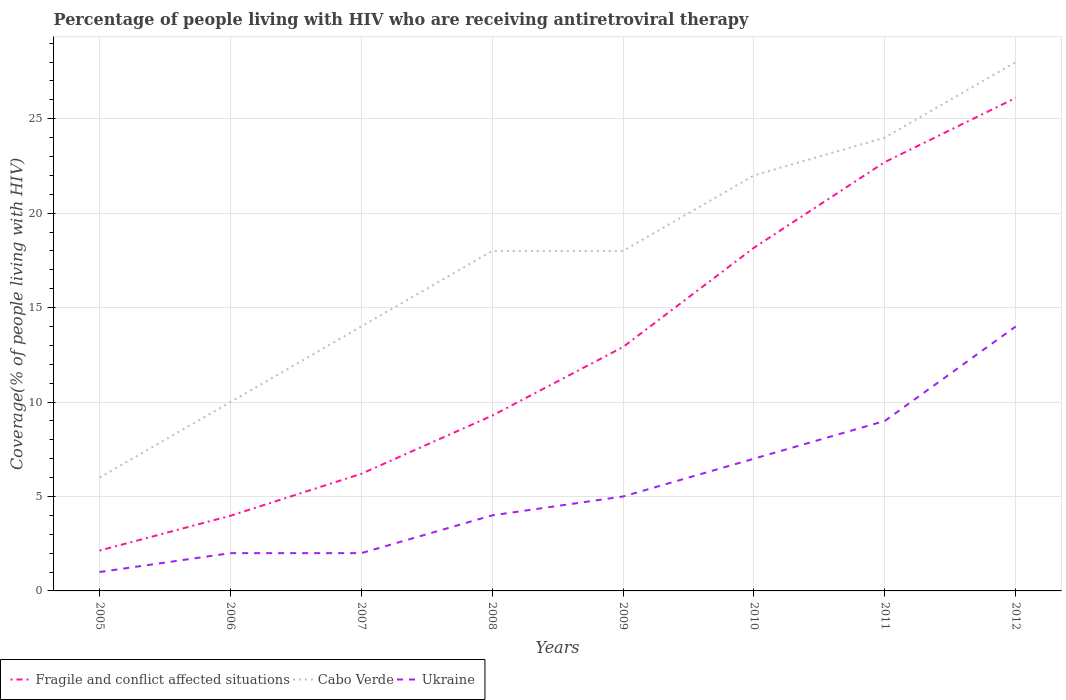How many different coloured lines are there?
Offer a terse response. 3. Across all years, what is the maximum percentage of the HIV infected people who are receiving antiretroviral therapy in Fragile and conflict affected situations?
Your response must be concise. 2.14. In which year was the percentage of the HIV infected people who are receiving antiretroviral therapy in Ukraine maximum?
Make the answer very short. 2005. What is the total percentage of the HIV infected people who are receiving antiretroviral therapy in Ukraine in the graph?
Your response must be concise. -6. What is the difference between the highest and the second highest percentage of the HIV infected people who are receiving antiretroviral therapy in Ukraine?
Your response must be concise. 13. How many lines are there?
Provide a short and direct response. 3. Does the graph contain any zero values?
Your response must be concise. No. Does the graph contain grids?
Offer a terse response. Yes. How many legend labels are there?
Offer a terse response. 3. What is the title of the graph?
Provide a succinct answer. Percentage of people living with HIV who are receiving antiretroviral therapy. Does "South Sudan" appear as one of the legend labels in the graph?
Give a very brief answer. No. What is the label or title of the Y-axis?
Your answer should be very brief. Coverage(% of people living with HIV). What is the Coverage(% of people living with HIV) in Fragile and conflict affected situations in 2005?
Make the answer very short. 2.14. What is the Coverage(% of people living with HIV) of Fragile and conflict affected situations in 2006?
Make the answer very short. 3.98. What is the Coverage(% of people living with HIV) of Cabo Verde in 2006?
Ensure brevity in your answer.  10. What is the Coverage(% of people living with HIV) in Fragile and conflict affected situations in 2007?
Ensure brevity in your answer.  6.2. What is the Coverage(% of people living with HIV) of Fragile and conflict affected situations in 2008?
Your answer should be very brief. 9.28. What is the Coverage(% of people living with HIV) in Cabo Verde in 2008?
Provide a succinct answer. 18. What is the Coverage(% of people living with HIV) of Ukraine in 2008?
Ensure brevity in your answer.  4. What is the Coverage(% of people living with HIV) of Fragile and conflict affected situations in 2009?
Give a very brief answer. 12.91. What is the Coverage(% of people living with HIV) of Cabo Verde in 2009?
Provide a short and direct response. 18. What is the Coverage(% of people living with HIV) of Ukraine in 2009?
Make the answer very short. 5. What is the Coverage(% of people living with HIV) of Fragile and conflict affected situations in 2010?
Make the answer very short. 18.17. What is the Coverage(% of people living with HIV) in Cabo Verde in 2010?
Ensure brevity in your answer.  22. What is the Coverage(% of people living with HIV) of Fragile and conflict affected situations in 2011?
Give a very brief answer. 22.7. What is the Coverage(% of people living with HIV) of Cabo Verde in 2011?
Your answer should be compact. 24. What is the Coverage(% of people living with HIV) of Fragile and conflict affected situations in 2012?
Ensure brevity in your answer.  26.1. What is the Coverage(% of people living with HIV) in Cabo Verde in 2012?
Provide a short and direct response. 28. Across all years, what is the maximum Coverage(% of people living with HIV) in Fragile and conflict affected situations?
Ensure brevity in your answer.  26.1. Across all years, what is the maximum Coverage(% of people living with HIV) in Ukraine?
Keep it short and to the point. 14. Across all years, what is the minimum Coverage(% of people living with HIV) of Fragile and conflict affected situations?
Provide a short and direct response. 2.14. Across all years, what is the minimum Coverage(% of people living with HIV) in Cabo Verde?
Provide a succinct answer. 6. What is the total Coverage(% of people living with HIV) in Fragile and conflict affected situations in the graph?
Offer a terse response. 101.49. What is the total Coverage(% of people living with HIV) in Cabo Verde in the graph?
Provide a short and direct response. 140. What is the difference between the Coverage(% of people living with HIV) in Fragile and conflict affected situations in 2005 and that in 2006?
Ensure brevity in your answer.  -1.84. What is the difference between the Coverage(% of people living with HIV) of Cabo Verde in 2005 and that in 2006?
Keep it short and to the point. -4. What is the difference between the Coverage(% of people living with HIV) in Ukraine in 2005 and that in 2006?
Provide a succinct answer. -1. What is the difference between the Coverage(% of people living with HIV) in Fragile and conflict affected situations in 2005 and that in 2007?
Offer a very short reply. -4.06. What is the difference between the Coverage(% of people living with HIV) of Ukraine in 2005 and that in 2007?
Provide a short and direct response. -1. What is the difference between the Coverage(% of people living with HIV) in Fragile and conflict affected situations in 2005 and that in 2008?
Your answer should be compact. -7.14. What is the difference between the Coverage(% of people living with HIV) of Cabo Verde in 2005 and that in 2008?
Ensure brevity in your answer.  -12. What is the difference between the Coverage(% of people living with HIV) in Fragile and conflict affected situations in 2005 and that in 2009?
Your response must be concise. -10.78. What is the difference between the Coverage(% of people living with HIV) in Cabo Verde in 2005 and that in 2009?
Give a very brief answer. -12. What is the difference between the Coverage(% of people living with HIV) in Fragile and conflict affected situations in 2005 and that in 2010?
Give a very brief answer. -16.03. What is the difference between the Coverage(% of people living with HIV) in Cabo Verde in 2005 and that in 2010?
Your answer should be very brief. -16. What is the difference between the Coverage(% of people living with HIV) of Ukraine in 2005 and that in 2010?
Offer a terse response. -6. What is the difference between the Coverage(% of people living with HIV) in Fragile and conflict affected situations in 2005 and that in 2011?
Provide a short and direct response. -20.57. What is the difference between the Coverage(% of people living with HIV) of Cabo Verde in 2005 and that in 2011?
Your response must be concise. -18. What is the difference between the Coverage(% of people living with HIV) of Ukraine in 2005 and that in 2011?
Keep it short and to the point. -8. What is the difference between the Coverage(% of people living with HIV) of Fragile and conflict affected situations in 2005 and that in 2012?
Offer a very short reply. -23.97. What is the difference between the Coverage(% of people living with HIV) in Fragile and conflict affected situations in 2006 and that in 2007?
Your answer should be compact. -2.22. What is the difference between the Coverage(% of people living with HIV) of Cabo Verde in 2006 and that in 2007?
Give a very brief answer. -4. What is the difference between the Coverage(% of people living with HIV) of Fragile and conflict affected situations in 2006 and that in 2008?
Offer a terse response. -5.3. What is the difference between the Coverage(% of people living with HIV) of Fragile and conflict affected situations in 2006 and that in 2009?
Provide a short and direct response. -8.94. What is the difference between the Coverage(% of people living with HIV) of Cabo Verde in 2006 and that in 2009?
Provide a succinct answer. -8. What is the difference between the Coverage(% of people living with HIV) of Ukraine in 2006 and that in 2009?
Your answer should be very brief. -3. What is the difference between the Coverage(% of people living with HIV) in Fragile and conflict affected situations in 2006 and that in 2010?
Keep it short and to the point. -14.19. What is the difference between the Coverage(% of people living with HIV) of Cabo Verde in 2006 and that in 2010?
Your answer should be compact. -12. What is the difference between the Coverage(% of people living with HIV) of Fragile and conflict affected situations in 2006 and that in 2011?
Provide a succinct answer. -18.73. What is the difference between the Coverage(% of people living with HIV) of Ukraine in 2006 and that in 2011?
Your response must be concise. -7. What is the difference between the Coverage(% of people living with HIV) of Fragile and conflict affected situations in 2006 and that in 2012?
Make the answer very short. -22.12. What is the difference between the Coverage(% of people living with HIV) in Ukraine in 2006 and that in 2012?
Provide a succinct answer. -12. What is the difference between the Coverage(% of people living with HIV) of Fragile and conflict affected situations in 2007 and that in 2008?
Make the answer very short. -3.08. What is the difference between the Coverage(% of people living with HIV) in Cabo Verde in 2007 and that in 2008?
Keep it short and to the point. -4. What is the difference between the Coverage(% of people living with HIV) in Ukraine in 2007 and that in 2008?
Offer a very short reply. -2. What is the difference between the Coverage(% of people living with HIV) in Fragile and conflict affected situations in 2007 and that in 2009?
Your answer should be very brief. -6.71. What is the difference between the Coverage(% of people living with HIV) in Ukraine in 2007 and that in 2009?
Your answer should be compact. -3. What is the difference between the Coverage(% of people living with HIV) of Fragile and conflict affected situations in 2007 and that in 2010?
Your answer should be compact. -11.97. What is the difference between the Coverage(% of people living with HIV) of Ukraine in 2007 and that in 2010?
Ensure brevity in your answer.  -5. What is the difference between the Coverage(% of people living with HIV) of Fragile and conflict affected situations in 2007 and that in 2011?
Your response must be concise. -16.5. What is the difference between the Coverage(% of people living with HIV) of Cabo Verde in 2007 and that in 2011?
Your answer should be very brief. -10. What is the difference between the Coverage(% of people living with HIV) of Fragile and conflict affected situations in 2007 and that in 2012?
Ensure brevity in your answer.  -19.9. What is the difference between the Coverage(% of people living with HIV) of Ukraine in 2007 and that in 2012?
Your answer should be compact. -12. What is the difference between the Coverage(% of people living with HIV) in Fragile and conflict affected situations in 2008 and that in 2009?
Offer a terse response. -3.63. What is the difference between the Coverage(% of people living with HIV) in Ukraine in 2008 and that in 2009?
Provide a short and direct response. -1. What is the difference between the Coverage(% of people living with HIV) in Fragile and conflict affected situations in 2008 and that in 2010?
Offer a very short reply. -8.89. What is the difference between the Coverage(% of people living with HIV) of Cabo Verde in 2008 and that in 2010?
Give a very brief answer. -4. What is the difference between the Coverage(% of people living with HIV) of Ukraine in 2008 and that in 2010?
Offer a very short reply. -3. What is the difference between the Coverage(% of people living with HIV) of Fragile and conflict affected situations in 2008 and that in 2011?
Give a very brief answer. -13.42. What is the difference between the Coverage(% of people living with HIV) of Cabo Verde in 2008 and that in 2011?
Your answer should be very brief. -6. What is the difference between the Coverage(% of people living with HIV) in Fragile and conflict affected situations in 2008 and that in 2012?
Make the answer very short. -16.82. What is the difference between the Coverage(% of people living with HIV) in Ukraine in 2008 and that in 2012?
Give a very brief answer. -10. What is the difference between the Coverage(% of people living with HIV) of Fragile and conflict affected situations in 2009 and that in 2010?
Make the answer very short. -5.25. What is the difference between the Coverage(% of people living with HIV) of Cabo Verde in 2009 and that in 2010?
Offer a very short reply. -4. What is the difference between the Coverage(% of people living with HIV) in Ukraine in 2009 and that in 2010?
Keep it short and to the point. -2. What is the difference between the Coverage(% of people living with HIV) of Fragile and conflict affected situations in 2009 and that in 2011?
Your answer should be compact. -9.79. What is the difference between the Coverage(% of people living with HIV) in Fragile and conflict affected situations in 2009 and that in 2012?
Offer a terse response. -13.19. What is the difference between the Coverage(% of people living with HIV) in Cabo Verde in 2009 and that in 2012?
Provide a succinct answer. -10. What is the difference between the Coverage(% of people living with HIV) in Fragile and conflict affected situations in 2010 and that in 2011?
Make the answer very short. -4.54. What is the difference between the Coverage(% of people living with HIV) of Fragile and conflict affected situations in 2010 and that in 2012?
Provide a succinct answer. -7.93. What is the difference between the Coverage(% of people living with HIV) in Cabo Verde in 2010 and that in 2012?
Your answer should be very brief. -6. What is the difference between the Coverage(% of people living with HIV) of Ukraine in 2010 and that in 2012?
Your response must be concise. -7. What is the difference between the Coverage(% of people living with HIV) in Fragile and conflict affected situations in 2011 and that in 2012?
Give a very brief answer. -3.4. What is the difference between the Coverage(% of people living with HIV) in Fragile and conflict affected situations in 2005 and the Coverage(% of people living with HIV) in Cabo Verde in 2006?
Your response must be concise. -7.86. What is the difference between the Coverage(% of people living with HIV) of Fragile and conflict affected situations in 2005 and the Coverage(% of people living with HIV) of Ukraine in 2006?
Ensure brevity in your answer.  0.14. What is the difference between the Coverage(% of people living with HIV) in Cabo Verde in 2005 and the Coverage(% of people living with HIV) in Ukraine in 2006?
Your response must be concise. 4. What is the difference between the Coverage(% of people living with HIV) in Fragile and conflict affected situations in 2005 and the Coverage(% of people living with HIV) in Cabo Verde in 2007?
Provide a short and direct response. -11.86. What is the difference between the Coverage(% of people living with HIV) of Fragile and conflict affected situations in 2005 and the Coverage(% of people living with HIV) of Ukraine in 2007?
Offer a very short reply. 0.14. What is the difference between the Coverage(% of people living with HIV) of Fragile and conflict affected situations in 2005 and the Coverage(% of people living with HIV) of Cabo Verde in 2008?
Ensure brevity in your answer.  -15.86. What is the difference between the Coverage(% of people living with HIV) of Fragile and conflict affected situations in 2005 and the Coverage(% of people living with HIV) of Ukraine in 2008?
Ensure brevity in your answer.  -1.86. What is the difference between the Coverage(% of people living with HIV) in Fragile and conflict affected situations in 2005 and the Coverage(% of people living with HIV) in Cabo Verde in 2009?
Make the answer very short. -15.86. What is the difference between the Coverage(% of people living with HIV) in Fragile and conflict affected situations in 2005 and the Coverage(% of people living with HIV) in Ukraine in 2009?
Provide a succinct answer. -2.86. What is the difference between the Coverage(% of people living with HIV) in Fragile and conflict affected situations in 2005 and the Coverage(% of people living with HIV) in Cabo Verde in 2010?
Ensure brevity in your answer.  -19.86. What is the difference between the Coverage(% of people living with HIV) in Fragile and conflict affected situations in 2005 and the Coverage(% of people living with HIV) in Ukraine in 2010?
Your answer should be very brief. -4.86. What is the difference between the Coverage(% of people living with HIV) of Cabo Verde in 2005 and the Coverage(% of people living with HIV) of Ukraine in 2010?
Make the answer very short. -1. What is the difference between the Coverage(% of people living with HIV) of Fragile and conflict affected situations in 2005 and the Coverage(% of people living with HIV) of Cabo Verde in 2011?
Provide a succinct answer. -21.86. What is the difference between the Coverage(% of people living with HIV) in Fragile and conflict affected situations in 2005 and the Coverage(% of people living with HIV) in Ukraine in 2011?
Provide a short and direct response. -6.86. What is the difference between the Coverage(% of people living with HIV) of Fragile and conflict affected situations in 2005 and the Coverage(% of people living with HIV) of Cabo Verde in 2012?
Ensure brevity in your answer.  -25.86. What is the difference between the Coverage(% of people living with HIV) in Fragile and conflict affected situations in 2005 and the Coverage(% of people living with HIV) in Ukraine in 2012?
Make the answer very short. -11.86. What is the difference between the Coverage(% of people living with HIV) of Fragile and conflict affected situations in 2006 and the Coverage(% of people living with HIV) of Cabo Verde in 2007?
Provide a short and direct response. -10.02. What is the difference between the Coverage(% of people living with HIV) of Fragile and conflict affected situations in 2006 and the Coverage(% of people living with HIV) of Ukraine in 2007?
Offer a very short reply. 1.98. What is the difference between the Coverage(% of people living with HIV) in Cabo Verde in 2006 and the Coverage(% of people living with HIV) in Ukraine in 2007?
Ensure brevity in your answer.  8. What is the difference between the Coverage(% of people living with HIV) of Fragile and conflict affected situations in 2006 and the Coverage(% of people living with HIV) of Cabo Verde in 2008?
Make the answer very short. -14.02. What is the difference between the Coverage(% of people living with HIV) of Fragile and conflict affected situations in 2006 and the Coverage(% of people living with HIV) of Ukraine in 2008?
Make the answer very short. -0.02. What is the difference between the Coverage(% of people living with HIV) in Cabo Verde in 2006 and the Coverage(% of people living with HIV) in Ukraine in 2008?
Make the answer very short. 6. What is the difference between the Coverage(% of people living with HIV) in Fragile and conflict affected situations in 2006 and the Coverage(% of people living with HIV) in Cabo Verde in 2009?
Offer a very short reply. -14.02. What is the difference between the Coverage(% of people living with HIV) in Fragile and conflict affected situations in 2006 and the Coverage(% of people living with HIV) in Ukraine in 2009?
Ensure brevity in your answer.  -1.02. What is the difference between the Coverage(% of people living with HIV) in Cabo Verde in 2006 and the Coverage(% of people living with HIV) in Ukraine in 2009?
Give a very brief answer. 5. What is the difference between the Coverage(% of people living with HIV) of Fragile and conflict affected situations in 2006 and the Coverage(% of people living with HIV) of Cabo Verde in 2010?
Keep it short and to the point. -18.02. What is the difference between the Coverage(% of people living with HIV) in Fragile and conflict affected situations in 2006 and the Coverage(% of people living with HIV) in Ukraine in 2010?
Keep it short and to the point. -3.02. What is the difference between the Coverage(% of people living with HIV) of Fragile and conflict affected situations in 2006 and the Coverage(% of people living with HIV) of Cabo Verde in 2011?
Provide a succinct answer. -20.02. What is the difference between the Coverage(% of people living with HIV) of Fragile and conflict affected situations in 2006 and the Coverage(% of people living with HIV) of Ukraine in 2011?
Ensure brevity in your answer.  -5.02. What is the difference between the Coverage(% of people living with HIV) of Cabo Verde in 2006 and the Coverage(% of people living with HIV) of Ukraine in 2011?
Offer a very short reply. 1. What is the difference between the Coverage(% of people living with HIV) in Fragile and conflict affected situations in 2006 and the Coverage(% of people living with HIV) in Cabo Verde in 2012?
Ensure brevity in your answer.  -24.02. What is the difference between the Coverage(% of people living with HIV) in Fragile and conflict affected situations in 2006 and the Coverage(% of people living with HIV) in Ukraine in 2012?
Your answer should be compact. -10.02. What is the difference between the Coverage(% of people living with HIV) in Fragile and conflict affected situations in 2007 and the Coverage(% of people living with HIV) in Cabo Verde in 2008?
Keep it short and to the point. -11.8. What is the difference between the Coverage(% of people living with HIV) of Fragile and conflict affected situations in 2007 and the Coverage(% of people living with HIV) of Ukraine in 2008?
Your response must be concise. 2.2. What is the difference between the Coverage(% of people living with HIV) in Cabo Verde in 2007 and the Coverage(% of people living with HIV) in Ukraine in 2008?
Make the answer very short. 10. What is the difference between the Coverage(% of people living with HIV) in Fragile and conflict affected situations in 2007 and the Coverage(% of people living with HIV) in Cabo Verde in 2009?
Make the answer very short. -11.8. What is the difference between the Coverage(% of people living with HIV) of Fragile and conflict affected situations in 2007 and the Coverage(% of people living with HIV) of Ukraine in 2009?
Your answer should be compact. 1.2. What is the difference between the Coverage(% of people living with HIV) in Fragile and conflict affected situations in 2007 and the Coverage(% of people living with HIV) in Cabo Verde in 2010?
Keep it short and to the point. -15.8. What is the difference between the Coverage(% of people living with HIV) in Fragile and conflict affected situations in 2007 and the Coverage(% of people living with HIV) in Ukraine in 2010?
Your response must be concise. -0.8. What is the difference between the Coverage(% of people living with HIV) of Fragile and conflict affected situations in 2007 and the Coverage(% of people living with HIV) of Cabo Verde in 2011?
Your answer should be very brief. -17.8. What is the difference between the Coverage(% of people living with HIV) of Fragile and conflict affected situations in 2007 and the Coverage(% of people living with HIV) of Ukraine in 2011?
Offer a very short reply. -2.8. What is the difference between the Coverage(% of people living with HIV) in Fragile and conflict affected situations in 2007 and the Coverage(% of people living with HIV) in Cabo Verde in 2012?
Your answer should be very brief. -21.8. What is the difference between the Coverage(% of people living with HIV) of Fragile and conflict affected situations in 2007 and the Coverage(% of people living with HIV) of Ukraine in 2012?
Provide a short and direct response. -7.8. What is the difference between the Coverage(% of people living with HIV) of Fragile and conflict affected situations in 2008 and the Coverage(% of people living with HIV) of Cabo Verde in 2009?
Ensure brevity in your answer.  -8.72. What is the difference between the Coverage(% of people living with HIV) of Fragile and conflict affected situations in 2008 and the Coverage(% of people living with HIV) of Ukraine in 2009?
Provide a short and direct response. 4.28. What is the difference between the Coverage(% of people living with HIV) of Cabo Verde in 2008 and the Coverage(% of people living with HIV) of Ukraine in 2009?
Provide a succinct answer. 13. What is the difference between the Coverage(% of people living with HIV) of Fragile and conflict affected situations in 2008 and the Coverage(% of people living with HIV) of Cabo Verde in 2010?
Provide a short and direct response. -12.72. What is the difference between the Coverage(% of people living with HIV) of Fragile and conflict affected situations in 2008 and the Coverage(% of people living with HIV) of Ukraine in 2010?
Your response must be concise. 2.28. What is the difference between the Coverage(% of people living with HIV) in Fragile and conflict affected situations in 2008 and the Coverage(% of people living with HIV) in Cabo Verde in 2011?
Offer a very short reply. -14.72. What is the difference between the Coverage(% of people living with HIV) of Fragile and conflict affected situations in 2008 and the Coverage(% of people living with HIV) of Ukraine in 2011?
Keep it short and to the point. 0.28. What is the difference between the Coverage(% of people living with HIV) of Fragile and conflict affected situations in 2008 and the Coverage(% of people living with HIV) of Cabo Verde in 2012?
Give a very brief answer. -18.72. What is the difference between the Coverage(% of people living with HIV) of Fragile and conflict affected situations in 2008 and the Coverage(% of people living with HIV) of Ukraine in 2012?
Offer a very short reply. -4.72. What is the difference between the Coverage(% of people living with HIV) of Fragile and conflict affected situations in 2009 and the Coverage(% of people living with HIV) of Cabo Verde in 2010?
Make the answer very short. -9.09. What is the difference between the Coverage(% of people living with HIV) in Fragile and conflict affected situations in 2009 and the Coverage(% of people living with HIV) in Ukraine in 2010?
Provide a short and direct response. 5.91. What is the difference between the Coverage(% of people living with HIV) of Cabo Verde in 2009 and the Coverage(% of people living with HIV) of Ukraine in 2010?
Offer a very short reply. 11. What is the difference between the Coverage(% of people living with HIV) in Fragile and conflict affected situations in 2009 and the Coverage(% of people living with HIV) in Cabo Verde in 2011?
Give a very brief answer. -11.09. What is the difference between the Coverage(% of people living with HIV) in Fragile and conflict affected situations in 2009 and the Coverage(% of people living with HIV) in Ukraine in 2011?
Offer a terse response. 3.91. What is the difference between the Coverage(% of people living with HIV) in Fragile and conflict affected situations in 2009 and the Coverage(% of people living with HIV) in Cabo Verde in 2012?
Offer a very short reply. -15.09. What is the difference between the Coverage(% of people living with HIV) of Fragile and conflict affected situations in 2009 and the Coverage(% of people living with HIV) of Ukraine in 2012?
Give a very brief answer. -1.09. What is the difference between the Coverage(% of people living with HIV) of Cabo Verde in 2009 and the Coverage(% of people living with HIV) of Ukraine in 2012?
Provide a short and direct response. 4. What is the difference between the Coverage(% of people living with HIV) of Fragile and conflict affected situations in 2010 and the Coverage(% of people living with HIV) of Cabo Verde in 2011?
Your answer should be very brief. -5.83. What is the difference between the Coverage(% of people living with HIV) of Fragile and conflict affected situations in 2010 and the Coverage(% of people living with HIV) of Ukraine in 2011?
Offer a terse response. 9.17. What is the difference between the Coverage(% of people living with HIV) of Cabo Verde in 2010 and the Coverage(% of people living with HIV) of Ukraine in 2011?
Your response must be concise. 13. What is the difference between the Coverage(% of people living with HIV) of Fragile and conflict affected situations in 2010 and the Coverage(% of people living with HIV) of Cabo Verde in 2012?
Offer a very short reply. -9.83. What is the difference between the Coverage(% of people living with HIV) in Fragile and conflict affected situations in 2010 and the Coverage(% of people living with HIV) in Ukraine in 2012?
Your response must be concise. 4.17. What is the difference between the Coverage(% of people living with HIV) of Cabo Verde in 2010 and the Coverage(% of people living with HIV) of Ukraine in 2012?
Keep it short and to the point. 8. What is the difference between the Coverage(% of people living with HIV) of Fragile and conflict affected situations in 2011 and the Coverage(% of people living with HIV) of Cabo Verde in 2012?
Provide a succinct answer. -5.3. What is the difference between the Coverage(% of people living with HIV) of Fragile and conflict affected situations in 2011 and the Coverage(% of people living with HIV) of Ukraine in 2012?
Provide a succinct answer. 8.7. What is the average Coverage(% of people living with HIV) in Fragile and conflict affected situations per year?
Offer a very short reply. 12.69. What is the average Coverage(% of people living with HIV) of Cabo Verde per year?
Offer a very short reply. 17.5. What is the average Coverage(% of people living with HIV) of Ukraine per year?
Offer a very short reply. 5.5. In the year 2005, what is the difference between the Coverage(% of people living with HIV) of Fragile and conflict affected situations and Coverage(% of people living with HIV) of Cabo Verde?
Provide a short and direct response. -3.86. In the year 2005, what is the difference between the Coverage(% of people living with HIV) of Fragile and conflict affected situations and Coverage(% of people living with HIV) of Ukraine?
Provide a short and direct response. 1.14. In the year 2005, what is the difference between the Coverage(% of people living with HIV) of Cabo Verde and Coverage(% of people living with HIV) of Ukraine?
Provide a short and direct response. 5. In the year 2006, what is the difference between the Coverage(% of people living with HIV) in Fragile and conflict affected situations and Coverage(% of people living with HIV) in Cabo Verde?
Provide a short and direct response. -6.02. In the year 2006, what is the difference between the Coverage(% of people living with HIV) in Fragile and conflict affected situations and Coverage(% of people living with HIV) in Ukraine?
Ensure brevity in your answer.  1.98. In the year 2006, what is the difference between the Coverage(% of people living with HIV) of Cabo Verde and Coverage(% of people living with HIV) of Ukraine?
Ensure brevity in your answer.  8. In the year 2007, what is the difference between the Coverage(% of people living with HIV) in Fragile and conflict affected situations and Coverage(% of people living with HIV) in Cabo Verde?
Your response must be concise. -7.8. In the year 2007, what is the difference between the Coverage(% of people living with HIV) in Fragile and conflict affected situations and Coverage(% of people living with HIV) in Ukraine?
Offer a terse response. 4.2. In the year 2008, what is the difference between the Coverage(% of people living with HIV) of Fragile and conflict affected situations and Coverage(% of people living with HIV) of Cabo Verde?
Ensure brevity in your answer.  -8.72. In the year 2008, what is the difference between the Coverage(% of people living with HIV) in Fragile and conflict affected situations and Coverage(% of people living with HIV) in Ukraine?
Ensure brevity in your answer.  5.28. In the year 2008, what is the difference between the Coverage(% of people living with HIV) of Cabo Verde and Coverage(% of people living with HIV) of Ukraine?
Your answer should be compact. 14. In the year 2009, what is the difference between the Coverage(% of people living with HIV) in Fragile and conflict affected situations and Coverage(% of people living with HIV) in Cabo Verde?
Your answer should be very brief. -5.09. In the year 2009, what is the difference between the Coverage(% of people living with HIV) in Fragile and conflict affected situations and Coverage(% of people living with HIV) in Ukraine?
Make the answer very short. 7.91. In the year 2009, what is the difference between the Coverage(% of people living with HIV) of Cabo Verde and Coverage(% of people living with HIV) of Ukraine?
Ensure brevity in your answer.  13. In the year 2010, what is the difference between the Coverage(% of people living with HIV) in Fragile and conflict affected situations and Coverage(% of people living with HIV) in Cabo Verde?
Offer a very short reply. -3.83. In the year 2010, what is the difference between the Coverage(% of people living with HIV) of Fragile and conflict affected situations and Coverage(% of people living with HIV) of Ukraine?
Offer a terse response. 11.17. In the year 2011, what is the difference between the Coverage(% of people living with HIV) of Fragile and conflict affected situations and Coverage(% of people living with HIV) of Cabo Verde?
Offer a terse response. -1.3. In the year 2011, what is the difference between the Coverage(% of people living with HIV) in Fragile and conflict affected situations and Coverage(% of people living with HIV) in Ukraine?
Your answer should be very brief. 13.7. In the year 2012, what is the difference between the Coverage(% of people living with HIV) in Fragile and conflict affected situations and Coverage(% of people living with HIV) in Cabo Verde?
Offer a very short reply. -1.9. In the year 2012, what is the difference between the Coverage(% of people living with HIV) in Fragile and conflict affected situations and Coverage(% of people living with HIV) in Ukraine?
Provide a short and direct response. 12.1. What is the ratio of the Coverage(% of people living with HIV) in Fragile and conflict affected situations in 2005 to that in 2006?
Your answer should be compact. 0.54. What is the ratio of the Coverage(% of people living with HIV) of Cabo Verde in 2005 to that in 2006?
Your response must be concise. 0.6. What is the ratio of the Coverage(% of people living with HIV) in Fragile and conflict affected situations in 2005 to that in 2007?
Your answer should be very brief. 0.34. What is the ratio of the Coverage(% of people living with HIV) in Cabo Verde in 2005 to that in 2007?
Make the answer very short. 0.43. What is the ratio of the Coverage(% of people living with HIV) of Ukraine in 2005 to that in 2007?
Offer a very short reply. 0.5. What is the ratio of the Coverage(% of people living with HIV) in Fragile and conflict affected situations in 2005 to that in 2008?
Offer a terse response. 0.23. What is the ratio of the Coverage(% of people living with HIV) of Fragile and conflict affected situations in 2005 to that in 2009?
Provide a short and direct response. 0.17. What is the ratio of the Coverage(% of people living with HIV) of Cabo Verde in 2005 to that in 2009?
Make the answer very short. 0.33. What is the ratio of the Coverage(% of people living with HIV) in Fragile and conflict affected situations in 2005 to that in 2010?
Keep it short and to the point. 0.12. What is the ratio of the Coverage(% of people living with HIV) in Cabo Verde in 2005 to that in 2010?
Ensure brevity in your answer.  0.27. What is the ratio of the Coverage(% of people living with HIV) of Ukraine in 2005 to that in 2010?
Make the answer very short. 0.14. What is the ratio of the Coverage(% of people living with HIV) in Fragile and conflict affected situations in 2005 to that in 2011?
Your answer should be very brief. 0.09. What is the ratio of the Coverage(% of people living with HIV) in Ukraine in 2005 to that in 2011?
Keep it short and to the point. 0.11. What is the ratio of the Coverage(% of people living with HIV) of Fragile and conflict affected situations in 2005 to that in 2012?
Give a very brief answer. 0.08. What is the ratio of the Coverage(% of people living with HIV) of Cabo Verde in 2005 to that in 2012?
Give a very brief answer. 0.21. What is the ratio of the Coverage(% of people living with HIV) of Ukraine in 2005 to that in 2012?
Offer a very short reply. 0.07. What is the ratio of the Coverage(% of people living with HIV) in Fragile and conflict affected situations in 2006 to that in 2007?
Give a very brief answer. 0.64. What is the ratio of the Coverage(% of people living with HIV) in Fragile and conflict affected situations in 2006 to that in 2008?
Make the answer very short. 0.43. What is the ratio of the Coverage(% of people living with HIV) of Cabo Verde in 2006 to that in 2008?
Your answer should be compact. 0.56. What is the ratio of the Coverage(% of people living with HIV) of Fragile and conflict affected situations in 2006 to that in 2009?
Offer a terse response. 0.31. What is the ratio of the Coverage(% of people living with HIV) in Cabo Verde in 2006 to that in 2009?
Make the answer very short. 0.56. What is the ratio of the Coverage(% of people living with HIV) of Ukraine in 2006 to that in 2009?
Your response must be concise. 0.4. What is the ratio of the Coverage(% of people living with HIV) of Fragile and conflict affected situations in 2006 to that in 2010?
Offer a very short reply. 0.22. What is the ratio of the Coverage(% of people living with HIV) of Cabo Verde in 2006 to that in 2010?
Offer a terse response. 0.45. What is the ratio of the Coverage(% of people living with HIV) of Ukraine in 2006 to that in 2010?
Make the answer very short. 0.29. What is the ratio of the Coverage(% of people living with HIV) of Fragile and conflict affected situations in 2006 to that in 2011?
Ensure brevity in your answer.  0.18. What is the ratio of the Coverage(% of people living with HIV) in Cabo Verde in 2006 to that in 2011?
Keep it short and to the point. 0.42. What is the ratio of the Coverage(% of people living with HIV) in Ukraine in 2006 to that in 2011?
Offer a very short reply. 0.22. What is the ratio of the Coverage(% of people living with HIV) in Fragile and conflict affected situations in 2006 to that in 2012?
Offer a very short reply. 0.15. What is the ratio of the Coverage(% of people living with HIV) of Cabo Verde in 2006 to that in 2012?
Your response must be concise. 0.36. What is the ratio of the Coverage(% of people living with HIV) of Ukraine in 2006 to that in 2012?
Give a very brief answer. 0.14. What is the ratio of the Coverage(% of people living with HIV) of Fragile and conflict affected situations in 2007 to that in 2008?
Keep it short and to the point. 0.67. What is the ratio of the Coverage(% of people living with HIV) of Ukraine in 2007 to that in 2008?
Offer a terse response. 0.5. What is the ratio of the Coverage(% of people living with HIV) of Fragile and conflict affected situations in 2007 to that in 2009?
Provide a succinct answer. 0.48. What is the ratio of the Coverage(% of people living with HIV) of Cabo Verde in 2007 to that in 2009?
Provide a short and direct response. 0.78. What is the ratio of the Coverage(% of people living with HIV) in Ukraine in 2007 to that in 2009?
Make the answer very short. 0.4. What is the ratio of the Coverage(% of people living with HIV) in Fragile and conflict affected situations in 2007 to that in 2010?
Offer a very short reply. 0.34. What is the ratio of the Coverage(% of people living with HIV) in Cabo Verde in 2007 to that in 2010?
Provide a succinct answer. 0.64. What is the ratio of the Coverage(% of people living with HIV) in Ukraine in 2007 to that in 2010?
Offer a terse response. 0.29. What is the ratio of the Coverage(% of people living with HIV) of Fragile and conflict affected situations in 2007 to that in 2011?
Your answer should be compact. 0.27. What is the ratio of the Coverage(% of people living with HIV) of Cabo Verde in 2007 to that in 2011?
Give a very brief answer. 0.58. What is the ratio of the Coverage(% of people living with HIV) in Ukraine in 2007 to that in 2011?
Your answer should be very brief. 0.22. What is the ratio of the Coverage(% of people living with HIV) of Fragile and conflict affected situations in 2007 to that in 2012?
Give a very brief answer. 0.24. What is the ratio of the Coverage(% of people living with HIV) in Ukraine in 2007 to that in 2012?
Your answer should be very brief. 0.14. What is the ratio of the Coverage(% of people living with HIV) in Fragile and conflict affected situations in 2008 to that in 2009?
Keep it short and to the point. 0.72. What is the ratio of the Coverage(% of people living with HIV) in Ukraine in 2008 to that in 2009?
Offer a very short reply. 0.8. What is the ratio of the Coverage(% of people living with HIV) of Fragile and conflict affected situations in 2008 to that in 2010?
Ensure brevity in your answer.  0.51. What is the ratio of the Coverage(% of people living with HIV) in Cabo Verde in 2008 to that in 2010?
Provide a short and direct response. 0.82. What is the ratio of the Coverage(% of people living with HIV) in Fragile and conflict affected situations in 2008 to that in 2011?
Ensure brevity in your answer.  0.41. What is the ratio of the Coverage(% of people living with HIV) in Ukraine in 2008 to that in 2011?
Keep it short and to the point. 0.44. What is the ratio of the Coverage(% of people living with HIV) of Fragile and conflict affected situations in 2008 to that in 2012?
Offer a terse response. 0.36. What is the ratio of the Coverage(% of people living with HIV) in Cabo Verde in 2008 to that in 2012?
Keep it short and to the point. 0.64. What is the ratio of the Coverage(% of people living with HIV) in Ukraine in 2008 to that in 2012?
Your answer should be very brief. 0.29. What is the ratio of the Coverage(% of people living with HIV) in Fragile and conflict affected situations in 2009 to that in 2010?
Ensure brevity in your answer.  0.71. What is the ratio of the Coverage(% of people living with HIV) in Cabo Verde in 2009 to that in 2010?
Your answer should be compact. 0.82. What is the ratio of the Coverage(% of people living with HIV) of Ukraine in 2009 to that in 2010?
Give a very brief answer. 0.71. What is the ratio of the Coverage(% of people living with HIV) in Fragile and conflict affected situations in 2009 to that in 2011?
Provide a succinct answer. 0.57. What is the ratio of the Coverage(% of people living with HIV) in Cabo Verde in 2009 to that in 2011?
Provide a short and direct response. 0.75. What is the ratio of the Coverage(% of people living with HIV) in Ukraine in 2009 to that in 2011?
Give a very brief answer. 0.56. What is the ratio of the Coverage(% of people living with HIV) of Fragile and conflict affected situations in 2009 to that in 2012?
Ensure brevity in your answer.  0.49. What is the ratio of the Coverage(% of people living with HIV) of Cabo Verde in 2009 to that in 2012?
Ensure brevity in your answer.  0.64. What is the ratio of the Coverage(% of people living with HIV) of Ukraine in 2009 to that in 2012?
Offer a terse response. 0.36. What is the ratio of the Coverage(% of people living with HIV) in Fragile and conflict affected situations in 2010 to that in 2011?
Provide a short and direct response. 0.8. What is the ratio of the Coverage(% of people living with HIV) of Ukraine in 2010 to that in 2011?
Provide a short and direct response. 0.78. What is the ratio of the Coverage(% of people living with HIV) of Fragile and conflict affected situations in 2010 to that in 2012?
Make the answer very short. 0.7. What is the ratio of the Coverage(% of people living with HIV) in Cabo Verde in 2010 to that in 2012?
Provide a short and direct response. 0.79. What is the ratio of the Coverage(% of people living with HIV) of Fragile and conflict affected situations in 2011 to that in 2012?
Keep it short and to the point. 0.87. What is the ratio of the Coverage(% of people living with HIV) of Cabo Verde in 2011 to that in 2012?
Your answer should be compact. 0.86. What is the ratio of the Coverage(% of people living with HIV) in Ukraine in 2011 to that in 2012?
Make the answer very short. 0.64. What is the difference between the highest and the second highest Coverage(% of people living with HIV) of Fragile and conflict affected situations?
Keep it short and to the point. 3.4. What is the difference between the highest and the second highest Coverage(% of people living with HIV) of Ukraine?
Offer a terse response. 5. What is the difference between the highest and the lowest Coverage(% of people living with HIV) in Fragile and conflict affected situations?
Provide a short and direct response. 23.97. 